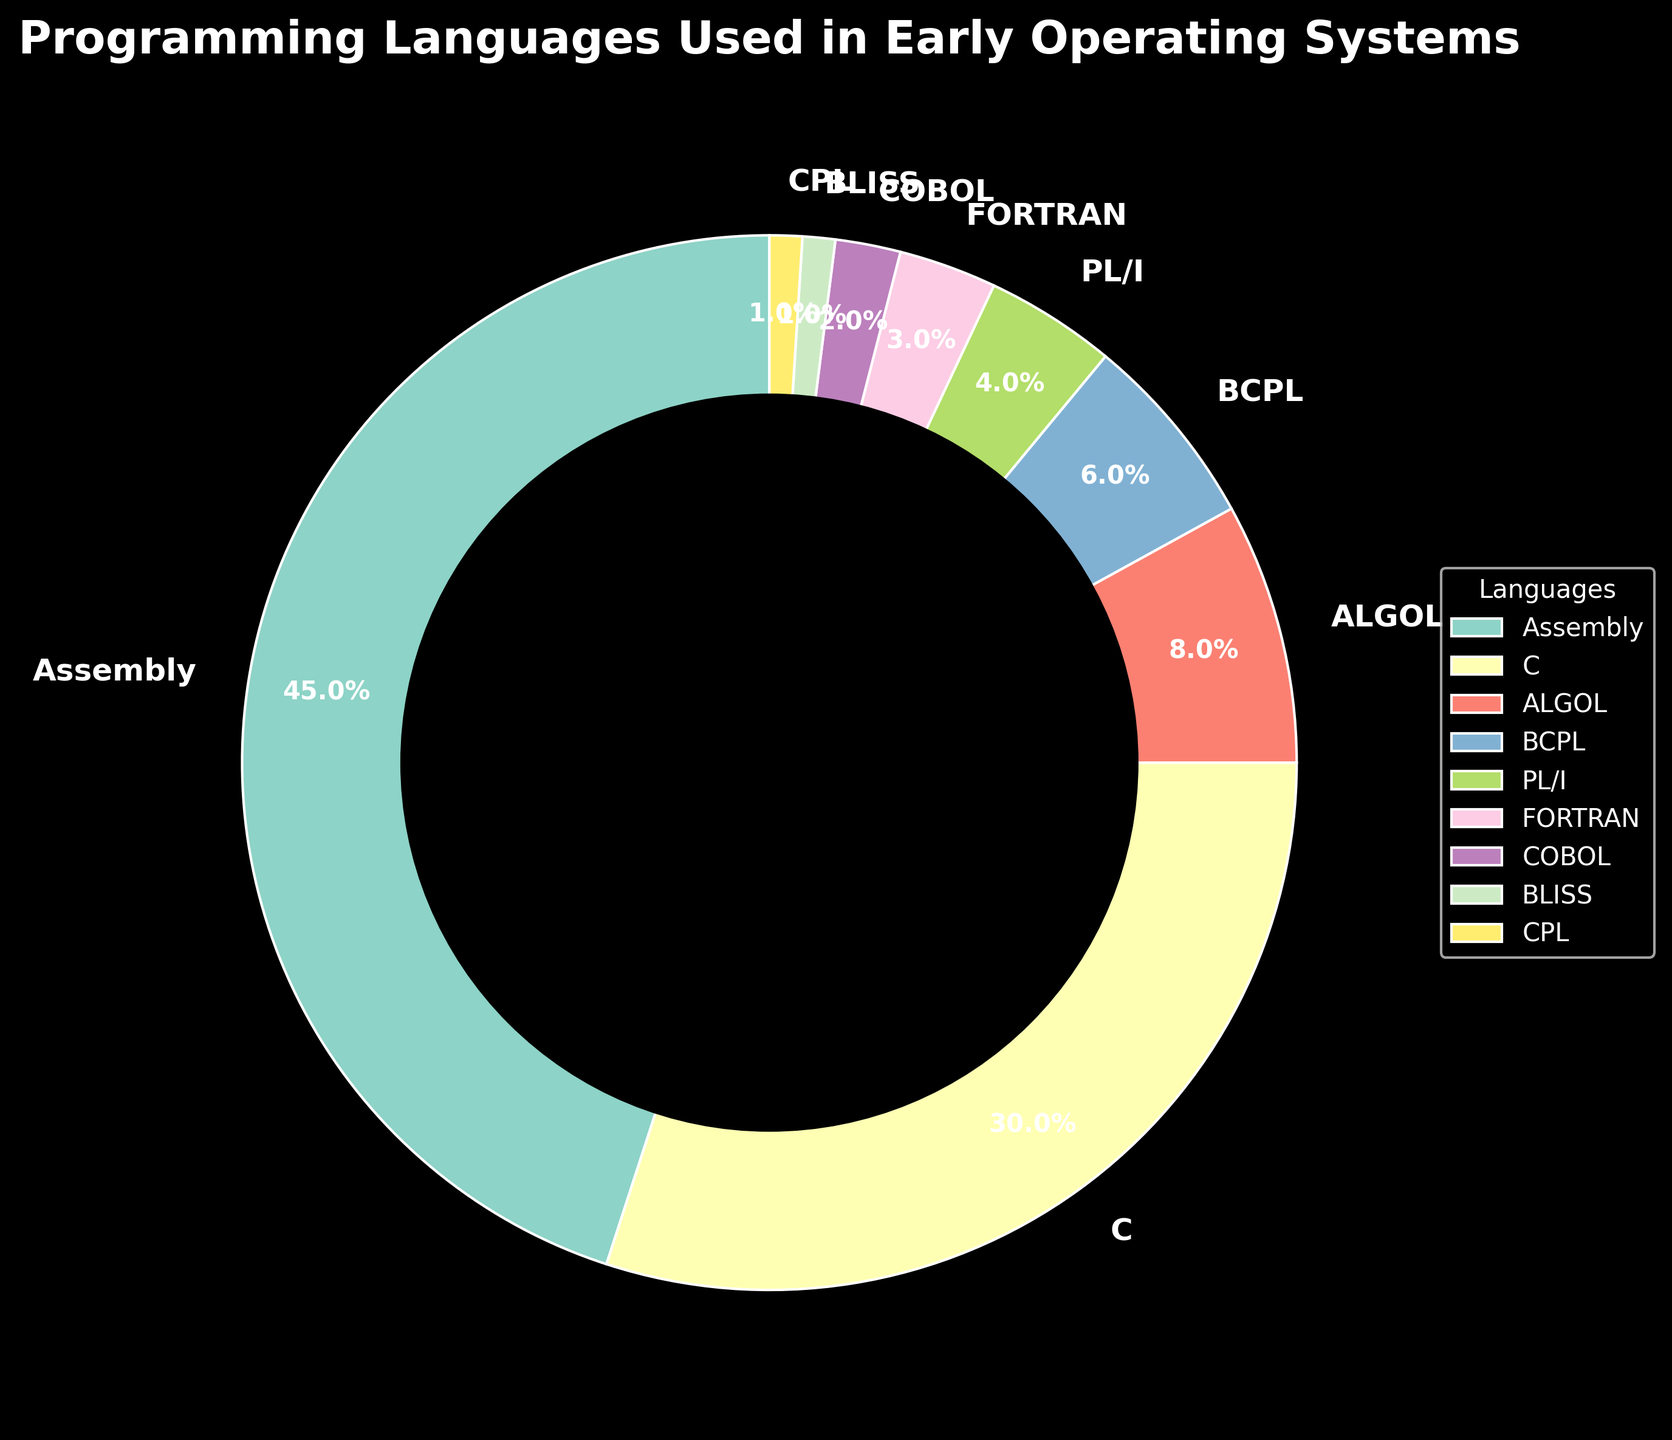How much more popular was Assembly compared to C? Assembly accounts for 45% and C accounts for 30%. The difference is 45% - 30% = 15%.
Answer: 15% Which language had the lowest usage in early operating systems, and what was its percentage? The figure shows that both BLISS and CPL have the lowest usage with each accounting for 1%.
Answer: BLISS and CPL: 1% What's the total percentage of the languages used that are not Assembly or C? The percentages for Assembly and C add up to 45% + 30% = 75%. Therefore, the remaining languages account for 100% - 75% = 25%.
Answer: 25% How does the total usage of ALGOL and BCPL compare to the usage of C? ALGOL has 8% and BCPL has 6%. Combined, ALGOL and BCPL account for 8% + 6% = 14%, which is less than C's 30%.
Answer: Less Which languages together make up less than 5% each? The figure shows PL/I (4%), FORTRAN (3%), COBOL (2%), BLISS (1%), and CPL (1%).
Answer: PL/I, FORTRAN, COBOL, BLISS, CPL Compare the percentage of usage between ALGOL and FORTRAN. Which is more utilized? The figure shows ALGOL at 8% and FORTRAN at 3%. ALGOL is more utilized.
Answer: ALGOL Combining the three least used languages, what is their total percentage? The three least used languages (BLISS, CPL, COBOl) have percentages of 1%, 1%, and 2% respectively. Combined, they account for 1% + 1% + 2% = 4%.
Answer: 4% Which two consecutive languages on the legend overlap in color the least visually? The legend uses distinct colors for the segments. The consecutive languages that overlap in color the least are COBOL and BLISS due to their distinctly different shades.
Answer: COBOL and BLISS What fraction of the pie chart is composed of Assembly and C combined? Assembly is 45% and C is 30%. Together, they make up 75% of the pie chart. The fraction is 75/100 = 3/4.
Answer: 3/4 